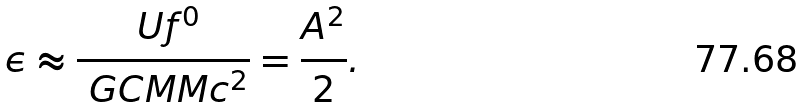<formula> <loc_0><loc_0><loc_500><loc_500>\epsilon \approx \frac { \ U f ^ { 0 } } { \ G C M M c ^ { 2 } } = \frac { A ^ { 2 } } { 2 } .</formula> 